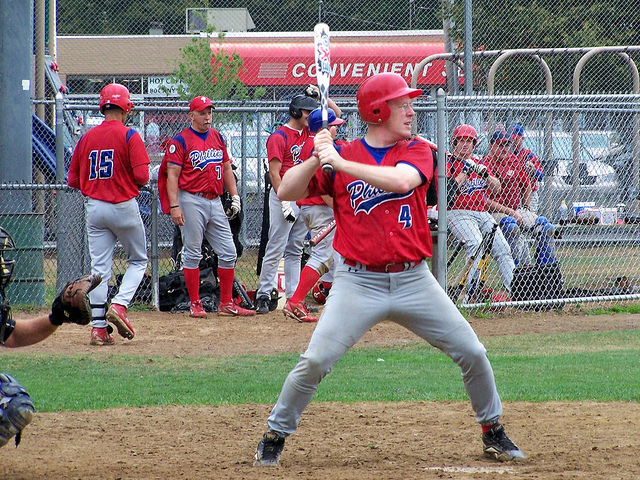<image>What is the name of this hitter? I don't know the name of this hitter. It could be Joe, Bob, Bill Patterson, Brain, or Phillip. Whose ballpark is represented here? I am not sure whose ballpark is represented here. It could either be 'phillies' or 'pharaohs'. Whose ballpark is represented here? I don't know whose ballpark is represented here. It could be the Phillies', but I am not sure. What is the name of this hitter? I am not sure what is the name of this hitter. It can be 'joe', 'bob', 'bill patterson', 'phillip', 'battery', 'brian', 'phil' or 'batter'. 